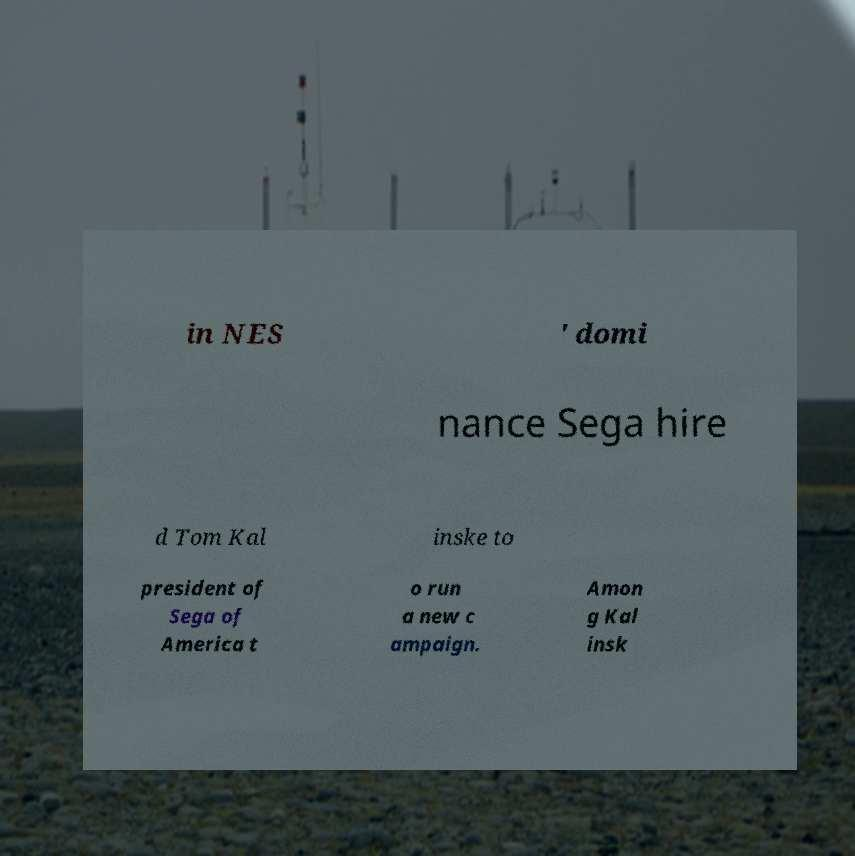Could you extract and type out the text from this image? in NES ' domi nance Sega hire d Tom Kal inske to president of Sega of America t o run a new c ampaign. Amon g Kal insk 